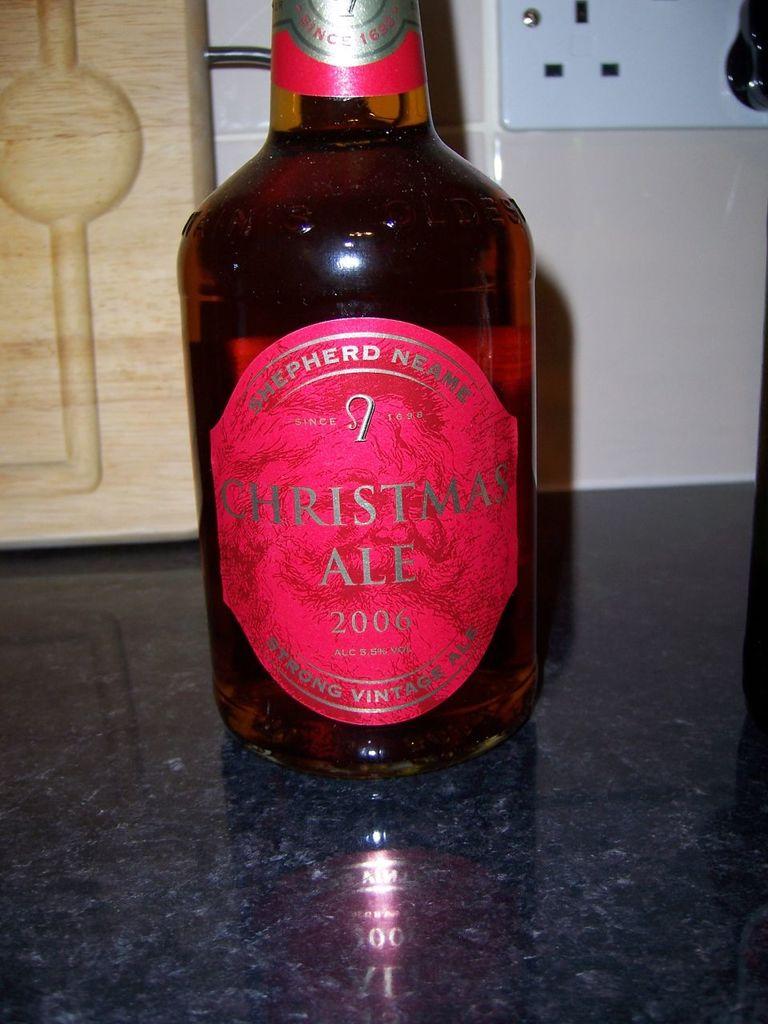What holiday is mentioned on the bottle?
Offer a very short reply. Christmas. What is the beverage year?
Keep it short and to the point. 2006. 